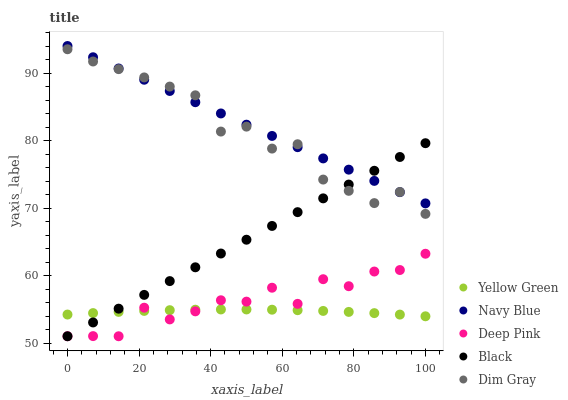Does Yellow Green have the minimum area under the curve?
Answer yes or no. Yes. Does Navy Blue have the maximum area under the curve?
Answer yes or no. Yes. Does Dim Gray have the minimum area under the curve?
Answer yes or no. No. Does Dim Gray have the maximum area under the curve?
Answer yes or no. No. Is Navy Blue the smoothest?
Answer yes or no. Yes. Is Deep Pink the roughest?
Answer yes or no. Yes. Is Dim Gray the smoothest?
Answer yes or no. No. Is Dim Gray the roughest?
Answer yes or no. No. Does Deep Pink have the lowest value?
Answer yes or no. Yes. Does Dim Gray have the lowest value?
Answer yes or no. No. Does Navy Blue have the highest value?
Answer yes or no. Yes. Does Dim Gray have the highest value?
Answer yes or no. No. Is Yellow Green less than Dim Gray?
Answer yes or no. Yes. Is Navy Blue greater than Deep Pink?
Answer yes or no. Yes. Does Navy Blue intersect Black?
Answer yes or no. Yes. Is Navy Blue less than Black?
Answer yes or no. No. Is Navy Blue greater than Black?
Answer yes or no. No. Does Yellow Green intersect Dim Gray?
Answer yes or no. No. 